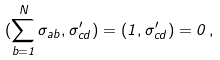Convert formula to latex. <formula><loc_0><loc_0><loc_500><loc_500>( \sum _ { b = 1 } ^ { N } \sigma _ { a b } , \sigma ^ { \prime } _ { c d } ) = ( 1 , \sigma ^ { \prime } _ { c d } ) = 0 \, ,</formula> 